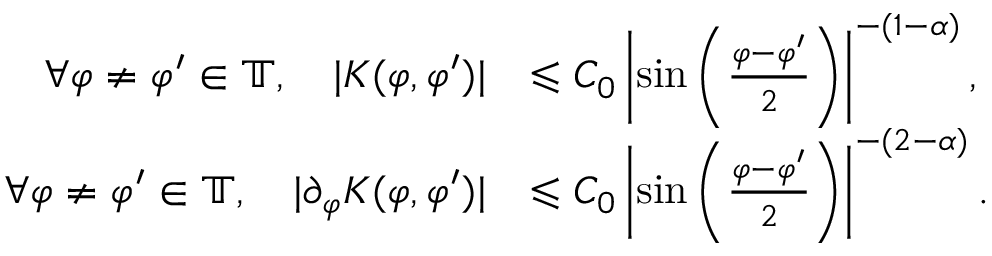<formula> <loc_0><loc_0><loc_500><loc_500>\begin{array} { r l } { \forall \varphi \neq \varphi ^ { \prime } \in \mathbb { T } , \quad | K ( \varphi , \varphi ^ { \prime } ) | } & { \leqslant C _ { 0 } \left | \sin \left ( \frac { \varphi - \varphi ^ { \prime } } { 2 } \right ) \right | ^ { - ( 1 - \alpha ) } , } \\ { \forall \varphi \neq \varphi ^ { \prime } \in \mathbb { T } , \quad | \partial _ { \varphi } K ( \varphi , \varphi ^ { \prime } ) | } & { \leqslant C _ { 0 } \left | \sin \left ( \frac { \varphi - \varphi ^ { \prime } } { 2 } \right ) \right | ^ { - ( 2 - \alpha ) } . } \end{array}</formula> 